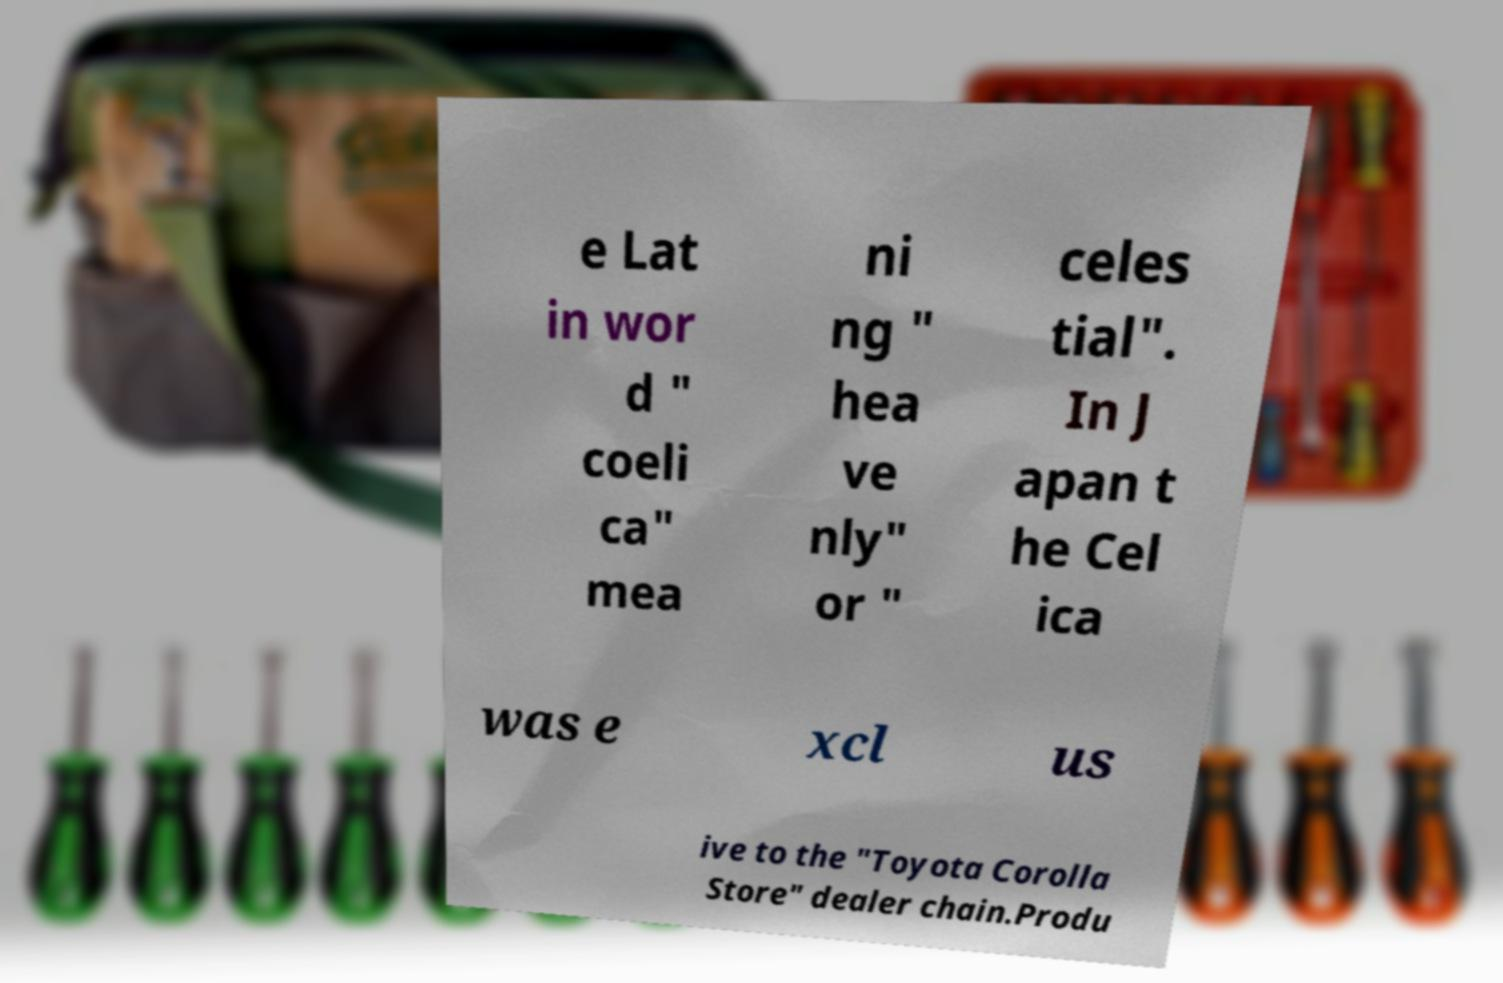Please identify and transcribe the text found in this image. e Lat in wor d " coeli ca" mea ni ng " hea ve nly" or " celes tial". In J apan t he Cel ica was e xcl us ive to the "Toyota Corolla Store" dealer chain.Produ 